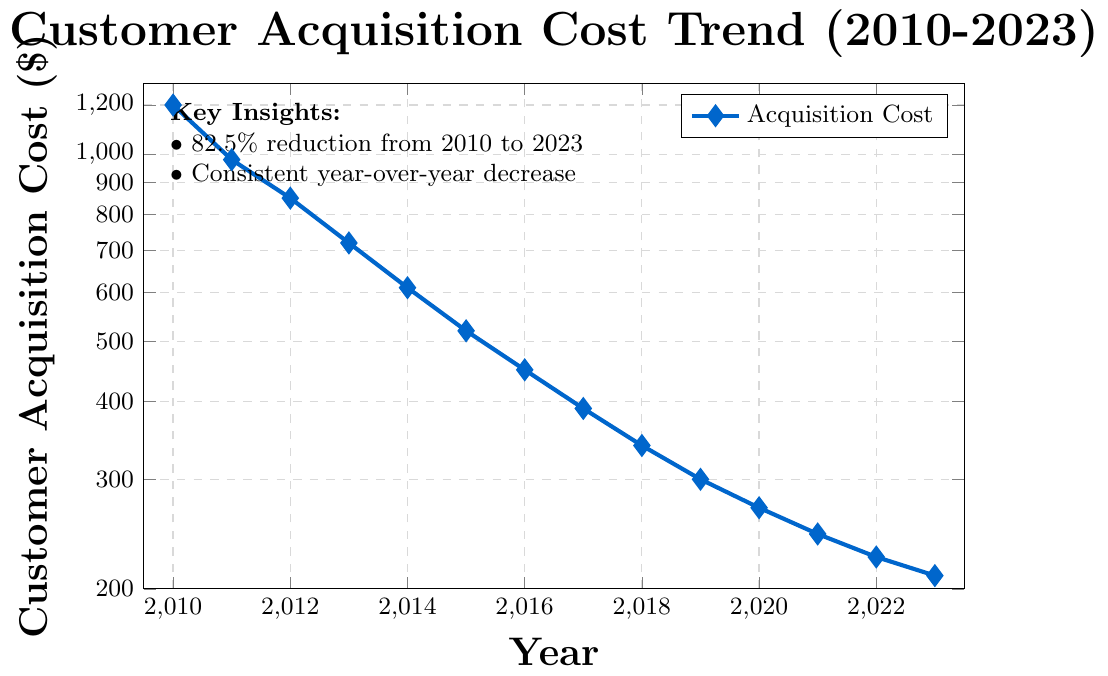What is the trend of customer acquisition costs from 2010 to 2023? The plot shows the customer acquisition costs from 2010 to 2023 on a logarithmic scale, decreasing from $1200 in 2010 to $210 in 2023, indicating a consistent decline in acquisition costs.
Answer: Consistent decline How much did the customer acquisition cost decrease from 2010 to 2023? In 2010, the cost was $1200, and in 2023 it was $210. Subtracting these values gives us 1200 - 210 = 990.
Answer: $990 Which year had the smallest customer acquisition cost and what was it? Referring to the plotted data, 2023 had the smallest customer acquisition cost, which was $210.
Answer: 2023, $210 By how much did the customer acquisition cost drop between 2011 and 2012? In 2011, the cost was $980, and in 2012 it was $850. The difference is 980 - 850 = 130.
Answer: $130 What is the percentage decrease in customer acquisition costs from 2014 to 2016? In 2014, the cost was $610, and in 2016 it was $450. The decrease is 610 - 450 = 160. The percentage decrease is (160/610) * 100 ≈ 26.23%.
Answer: ≈ 26.23% Is there any year where the customer acquisition cost increased compared to the previous year? There is no indication in the plot that the customer acquisition cost increased in any given year; it consistently decreased year over year.
Answer: No What does the color of the data points in the plot indicate? The plotted data points, which are marked in blue color, consistently represent the customer acquisition costs over the years. The color indicates the series of acquisition costs.
Answer: Acquisition costs series In which year did the customer acquisition cost first fall below $500? According to the plot, the cost first fell below $500 in the year 2016.
Answer: 2016 What was the customer acquisition cost in the year 2018 compared to 2020? In 2018, the cost was $340, and in 2020 it was $270. 2020 had a lower cost by 340 - 270 = 70.
Answer: $340 vs $270 How many total years are considered in the plotted data, and what is the average annual decrease in the cost from the starting to the ending year? There are 14 years from 2010 to 2023 in the plotted data. The total decrease is 1200 - 210 = 990. The average annual decrease is 990 / 13 ≈ 76.15.
Answer: 14 years, ≈ $76.15 per year 